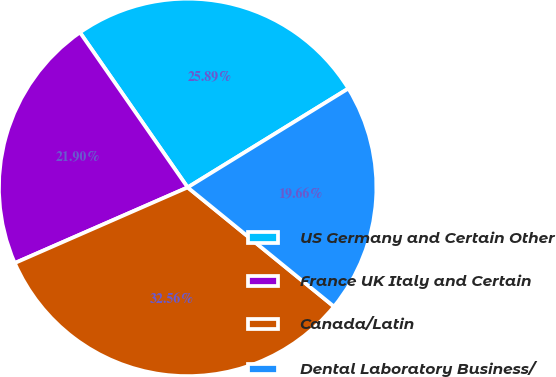Convert chart to OTSL. <chart><loc_0><loc_0><loc_500><loc_500><pie_chart><fcel>US Germany and Certain Other<fcel>France UK Italy and Certain<fcel>Canada/Latin<fcel>Dental Laboratory Business/<nl><fcel>25.89%<fcel>21.9%<fcel>32.56%<fcel>19.66%<nl></chart> 